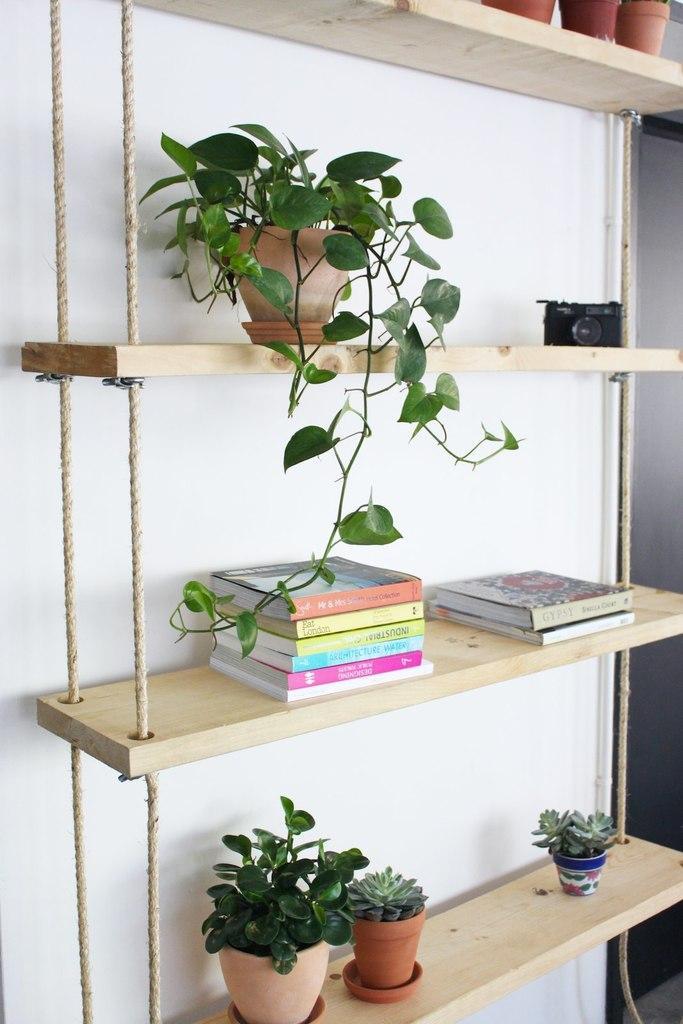Please provide a concise description of this image. In this image I can see few flowertots, books, camera on the wooden shelves. Background is in white color. 